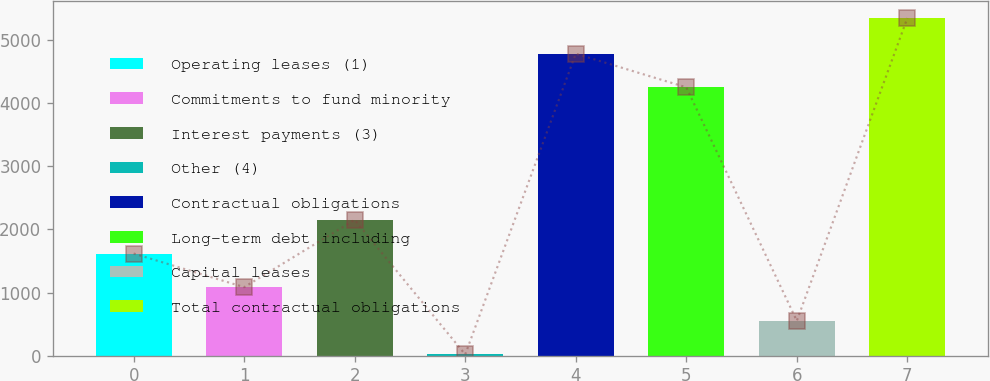Convert chart. <chart><loc_0><loc_0><loc_500><loc_500><bar_chart><fcel>Operating leases (1)<fcel>Commitments to fund minority<fcel>Interest payments (3)<fcel>Other (4)<fcel>Contractual obligations<fcel>Long-term debt including<fcel>Capital leases<fcel>Total contractual obligations<nl><fcel>1618.2<fcel>1084.8<fcel>2151.6<fcel>18<fcel>4786.4<fcel>4253<fcel>551.4<fcel>5352<nl></chart> 